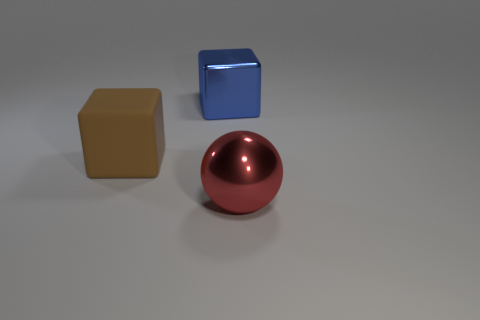Does the metallic thing that is in front of the brown rubber block have the same size as the metal thing on the left side of the metallic sphere?
Make the answer very short. Yes. What is the material of the cube that is to the left of the large shiny object left of the metal sphere?
Provide a short and direct response. Rubber. Are there fewer cubes that are to the right of the blue metallic object than large metallic blocks to the left of the red object?
Keep it short and to the point. Yes. Are there any other things that have the same shape as the red object?
Your answer should be compact. No. There is a large cube that is right of the large rubber object; what material is it?
Make the answer very short. Metal. Are there any red objects in front of the ball?
Provide a short and direct response. No. There is a blue metallic thing; what shape is it?
Your answer should be compact. Cube. What number of things are either large metallic things that are behind the large ball or big brown matte cubes?
Keep it short and to the point. 2. How many other things are the same color as the rubber object?
Your answer should be compact. 0. There is another thing that is the same shape as the matte object; what color is it?
Ensure brevity in your answer.  Blue. 